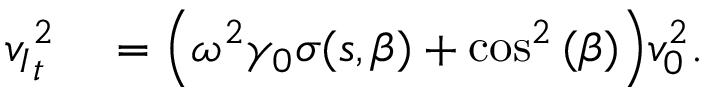<formula> <loc_0><loc_0><loc_500><loc_500>\begin{array} { r l } { { v _ { I } } _ { t } ^ { 2 } } & \left ( \omega ^ { 2 } \gamma _ { 0 } \sigma ( s , \beta ) + \cos ^ { 2 } { ( \beta ) } \right ) v _ { 0 } ^ { 2 } . } \end{array}</formula> 